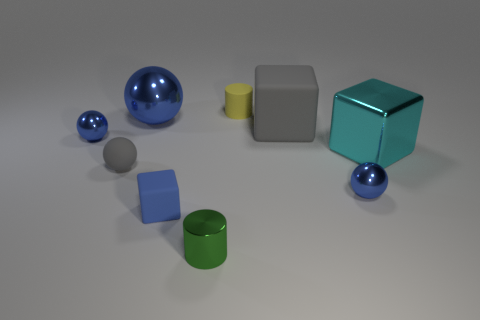Are there any other things that have the same shape as the big rubber object?
Ensure brevity in your answer.  Yes. What number of objects are cubes that are on the right side of the shiny cylinder or tiny metal cylinders?
Your answer should be compact. 3. There is a big shiny object that is in front of the big gray rubber object; does it have the same color as the tiny rubber ball?
Provide a short and direct response. No. There is a object that is to the right of the blue metallic ball that is on the right side of the small green cylinder; what is its shape?
Make the answer very short. Cube. Is the number of large gray rubber blocks to the right of the large metallic block less than the number of blue metallic balls that are to the left of the big gray rubber thing?
Provide a short and direct response. Yes. The matte thing that is the same shape as the large blue metallic object is what size?
Your answer should be very brief. Small. Is there anything else that has the same size as the gray rubber ball?
Offer a terse response. Yes. How many things are either small metallic balls right of the small gray rubber ball or gray objects to the right of the tiny green metallic cylinder?
Ensure brevity in your answer.  2. Is the size of the green cylinder the same as the yellow thing?
Give a very brief answer. Yes. Are there more tiny purple balls than large cyan metal cubes?
Give a very brief answer. No. 